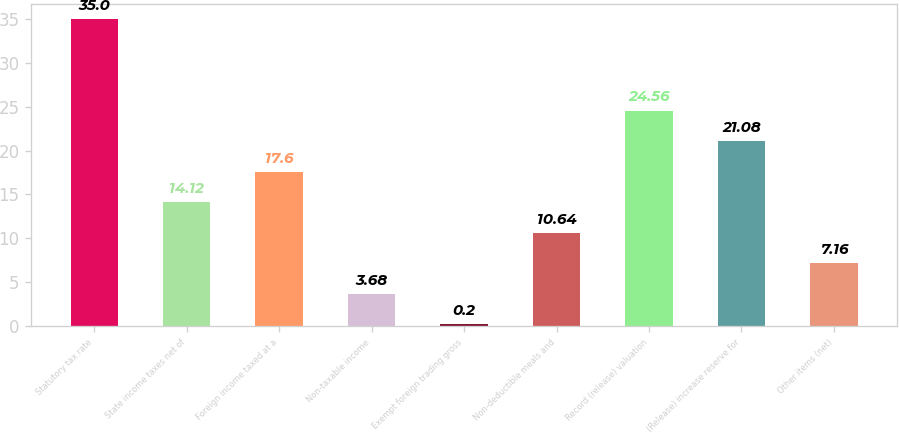Convert chart. <chart><loc_0><loc_0><loc_500><loc_500><bar_chart><fcel>Statutory tax rate<fcel>State income taxes net of<fcel>Foreign income taxed at a<fcel>Non-taxable income<fcel>Exempt foreign trading gross<fcel>Non-deductible meals and<fcel>Record (release) valuation<fcel>(Release) increase reserve for<fcel>Other items (net)<nl><fcel>35<fcel>14.12<fcel>17.6<fcel>3.68<fcel>0.2<fcel>10.64<fcel>24.56<fcel>21.08<fcel>7.16<nl></chart> 